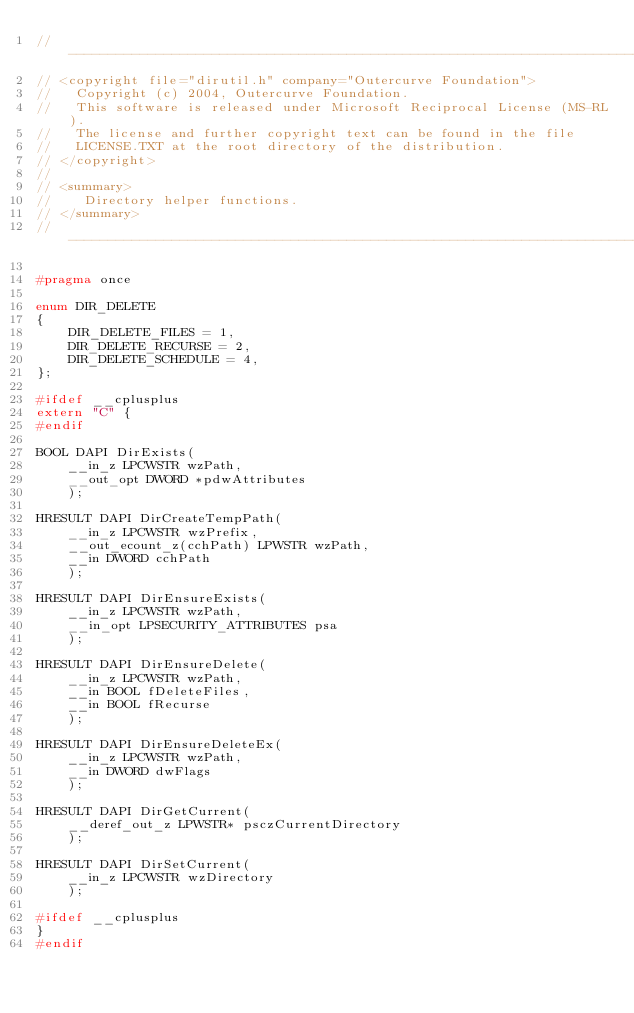Convert code to text. <code><loc_0><loc_0><loc_500><loc_500><_C_>//-------------------------------------------------------------------------------------------------
// <copyright file="dirutil.h" company="Outercurve Foundation">
//   Copyright (c) 2004, Outercurve Foundation.
//   This software is released under Microsoft Reciprocal License (MS-RL).
//   The license and further copyright text can be found in the file
//   LICENSE.TXT at the root directory of the distribution.
// </copyright>
// 
// <summary>
//    Directory helper functions.
// </summary>
//-------------------------------------------------------------------------------------------------

#pragma once

enum DIR_DELETE
{
    DIR_DELETE_FILES = 1,
    DIR_DELETE_RECURSE = 2,
    DIR_DELETE_SCHEDULE = 4,
};

#ifdef __cplusplus
extern "C" {
#endif

BOOL DAPI DirExists(
    __in_z LPCWSTR wzPath, 
    __out_opt DWORD *pdwAttributes
    );

HRESULT DAPI DirCreateTempPath(
    __in_z LPCWSTR wzPrefix,
    __out_ecount_z(cchPath) LPWSTR wzPath,
    __in DWORD cchPath
    );

HRESULT DAPI DirEnsureExists(
    __in_z LPCWSTR wzPath, 
    __in_opt LPSECURITY_ATTRIBUTES psa
    );

HRESULT DAPI DirEnsureDelete(
    __in_z LPCWSTR wzPath,
    __in BOOL fDeleteFiles,
    __in BOOL fRecurse
    );

HRESULT DAPI DirEnsureDeleteEx(
    __in_z LPCWSTR wzPath,
    __in DWORD dwFlags
    );

HRESULT DAPI DirGetCurrent(
    __deref_out_z LPWSTR* psczCurrentDirectory
    );

HRESULT DAPI DirSetCurrent(
    __in_z LPCWSTR wzDirectory
    );

#ifdef __cplusplus
}
#endif

</code> 